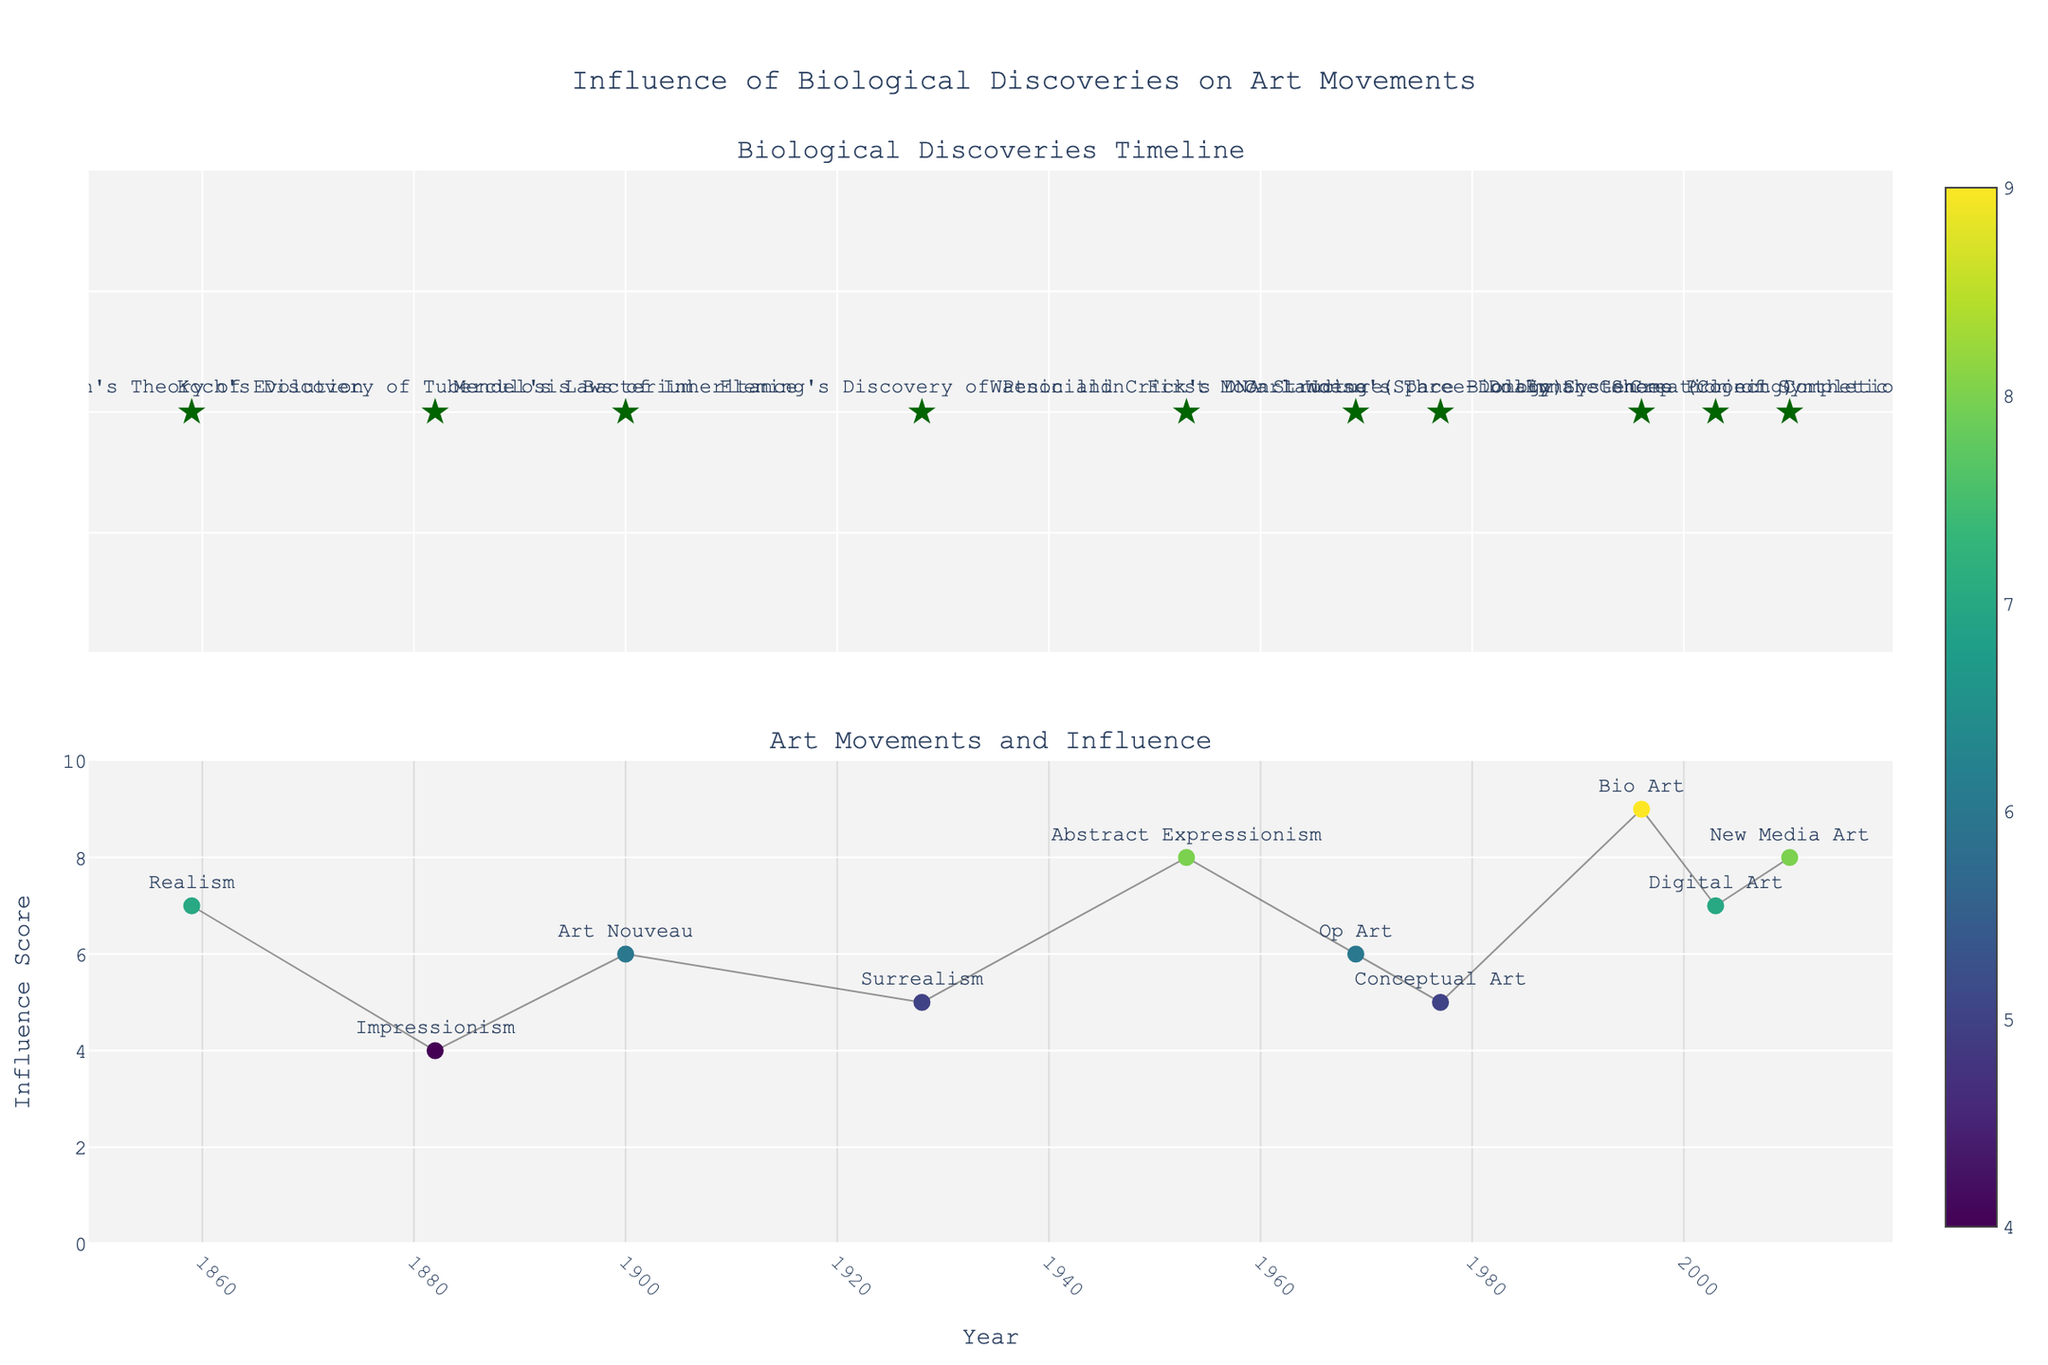what is the color of the markers for biological discoveries? The markers for biological discoveries are depicted as dark green stars in the upper plot.
Answer: dark green What is the height of the influence score for Dolly the Sheep in 1996? The influence score for Dolly the Sheep marked on the second subplot shows up at a height of 9. The score is represented by a marker along the y-axis with a value of 9.
Answer: 9 Which art movement peaked around the midpoint of the timeline regarding its influence score? The art movement with the highest influence score around the midpoint is Abstract Expressionism, linked to Watson and Crick's DNA Structure discovery in 1953.
Answer: Abstract Expressionism Identify the earliest biological discovery included in the figure. The earliest biological discovery is Darwin's Theory of Evolution in 1859, featured at the far left of the top subplot.
Answer: Darwin's Theory of Evolution Which art movement is associated with the highest influence score in the dataset? Bio Art, associated with Dolly the Sheep cloning in 1996, has the highest influence score of 9, marked in the second subplot.
Answer: Bio Art What is the mean influence score for all the art movements represented in the timeline? Adding up all the influence scores (7 + 4 + 6 + 5 + 8 + 6 + 5 + 9 + 7 + 8) gives 65. With 10 data points, the mean is 65/10.
Answer: 6.5 Compare the influence scores of Art Nouveau and New Media Art. Which one is higher? Art Nouveau has an influence score of 6, and New Media Art has a score of 8. Comparing the two, New Media Art has a higher score.
Answer: New Media Art How many years separate the discovery of Mendel's Laws of Inheritance and the creation of synthetic life? Mendel's Laws of Inheritance were discovered in 1900 and synthetic life was created in 2010. The number of years between these events is 2010 - 1900.
Answer: 110 years What is the title of the lower subplot? The lower subplot is titled "Art Movements and Influence," as specified within the figure’s layout.
Answer: Art Movements and Influence 